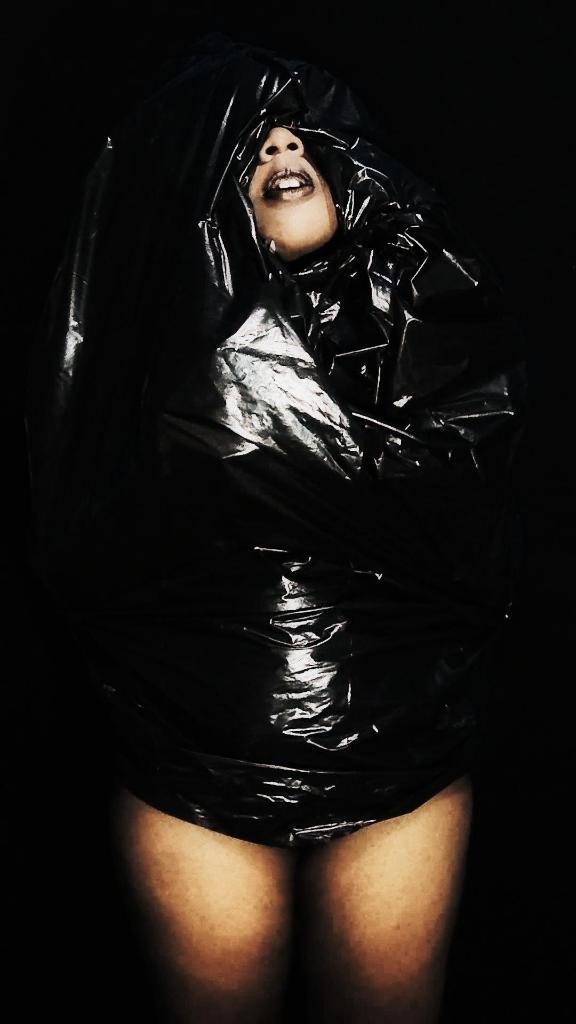In one or two sentences, can you explain what this image depicts? In this image we can see one person covering with a mask. 